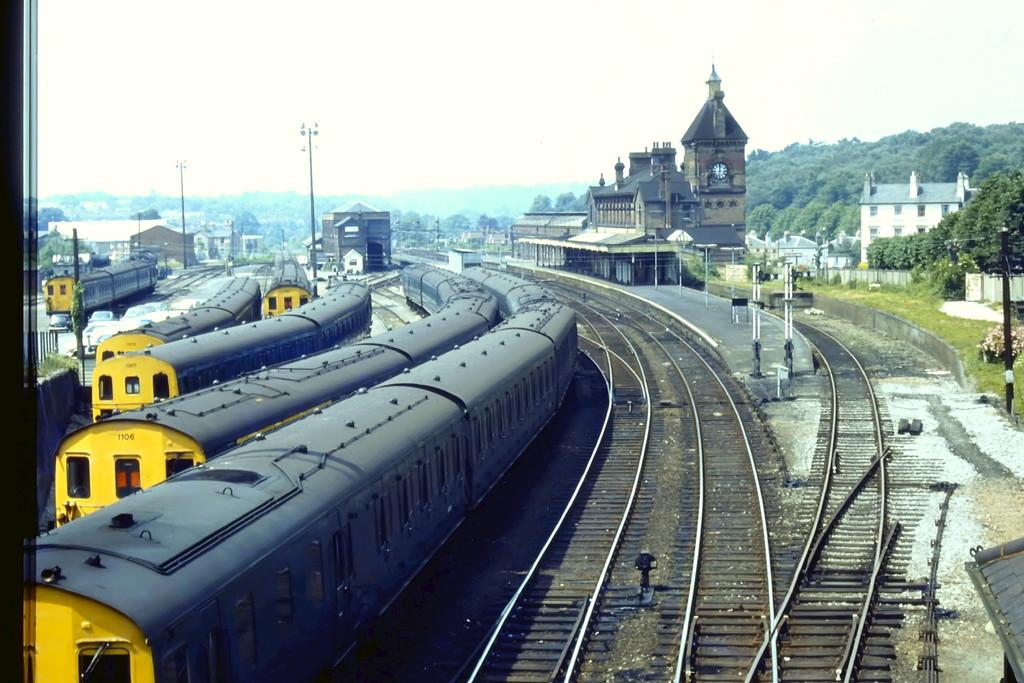What is the main subject in the center of the image? There are trains in the center of the image. What are the trains traveling on? There are tracks in the center of the image for the trains to travel on. What can be seen in the background of the image? There are poles, buildings, and trees in the background of the image. What type of health advice can be seen on the buildings in the image? There is no health advice visible on the buildings in the image; the buildings are simply part of the background. 